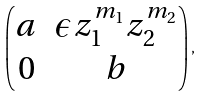<formula> <loc_0><loc_0><loc_500><loc_500>\begin{pmatrix} a & \epsilon z _ { 1 } ^ { m _ { 1 } } z _ { 2 } ^ { m _ { 2 } } \\ 0 & b \end{pmatrix} ,</formula> 